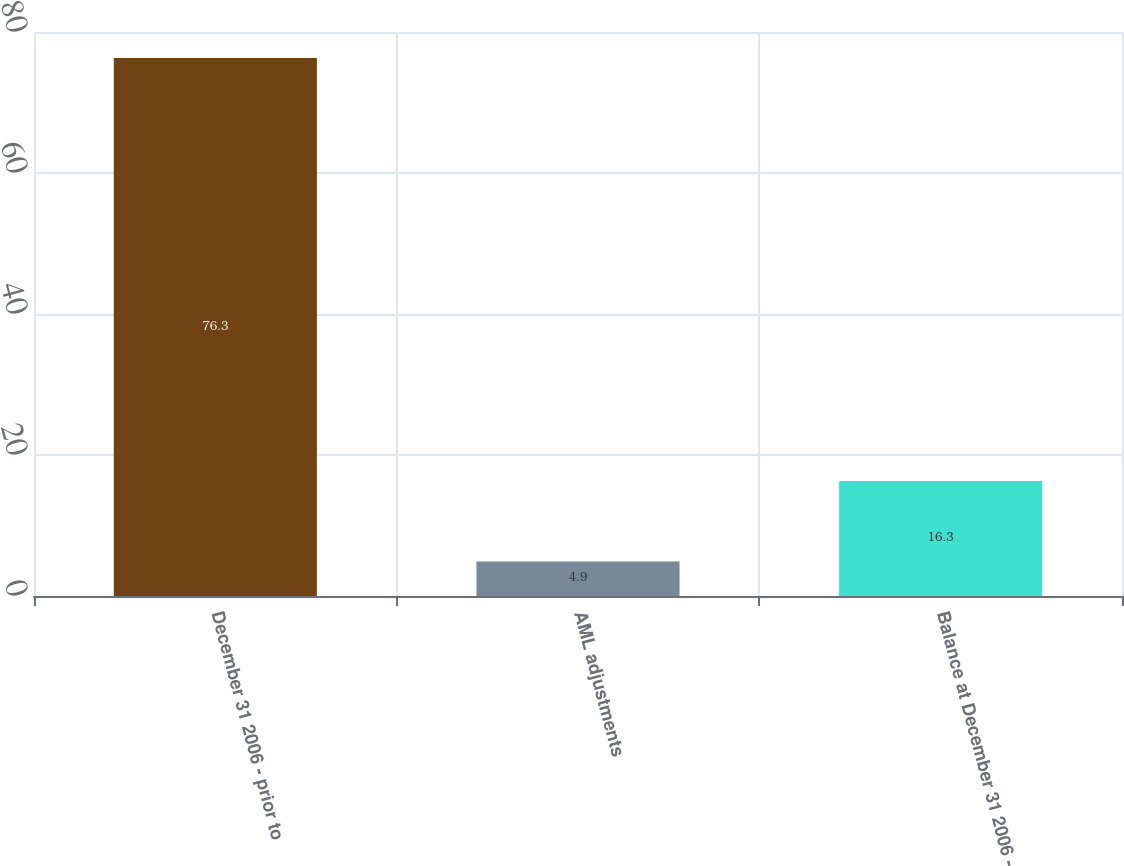Convert chart to OTSL. <chart><loc_0><loc_0><loc_500><loc_500><bar_chart><fcel>December 31 2006 - prior to<fcel>AML adjustments<fcel>Balance at December 31 2006 -<nl><fcel>76.3<fcel>4.9<fcel>16.3<nl></chart> 